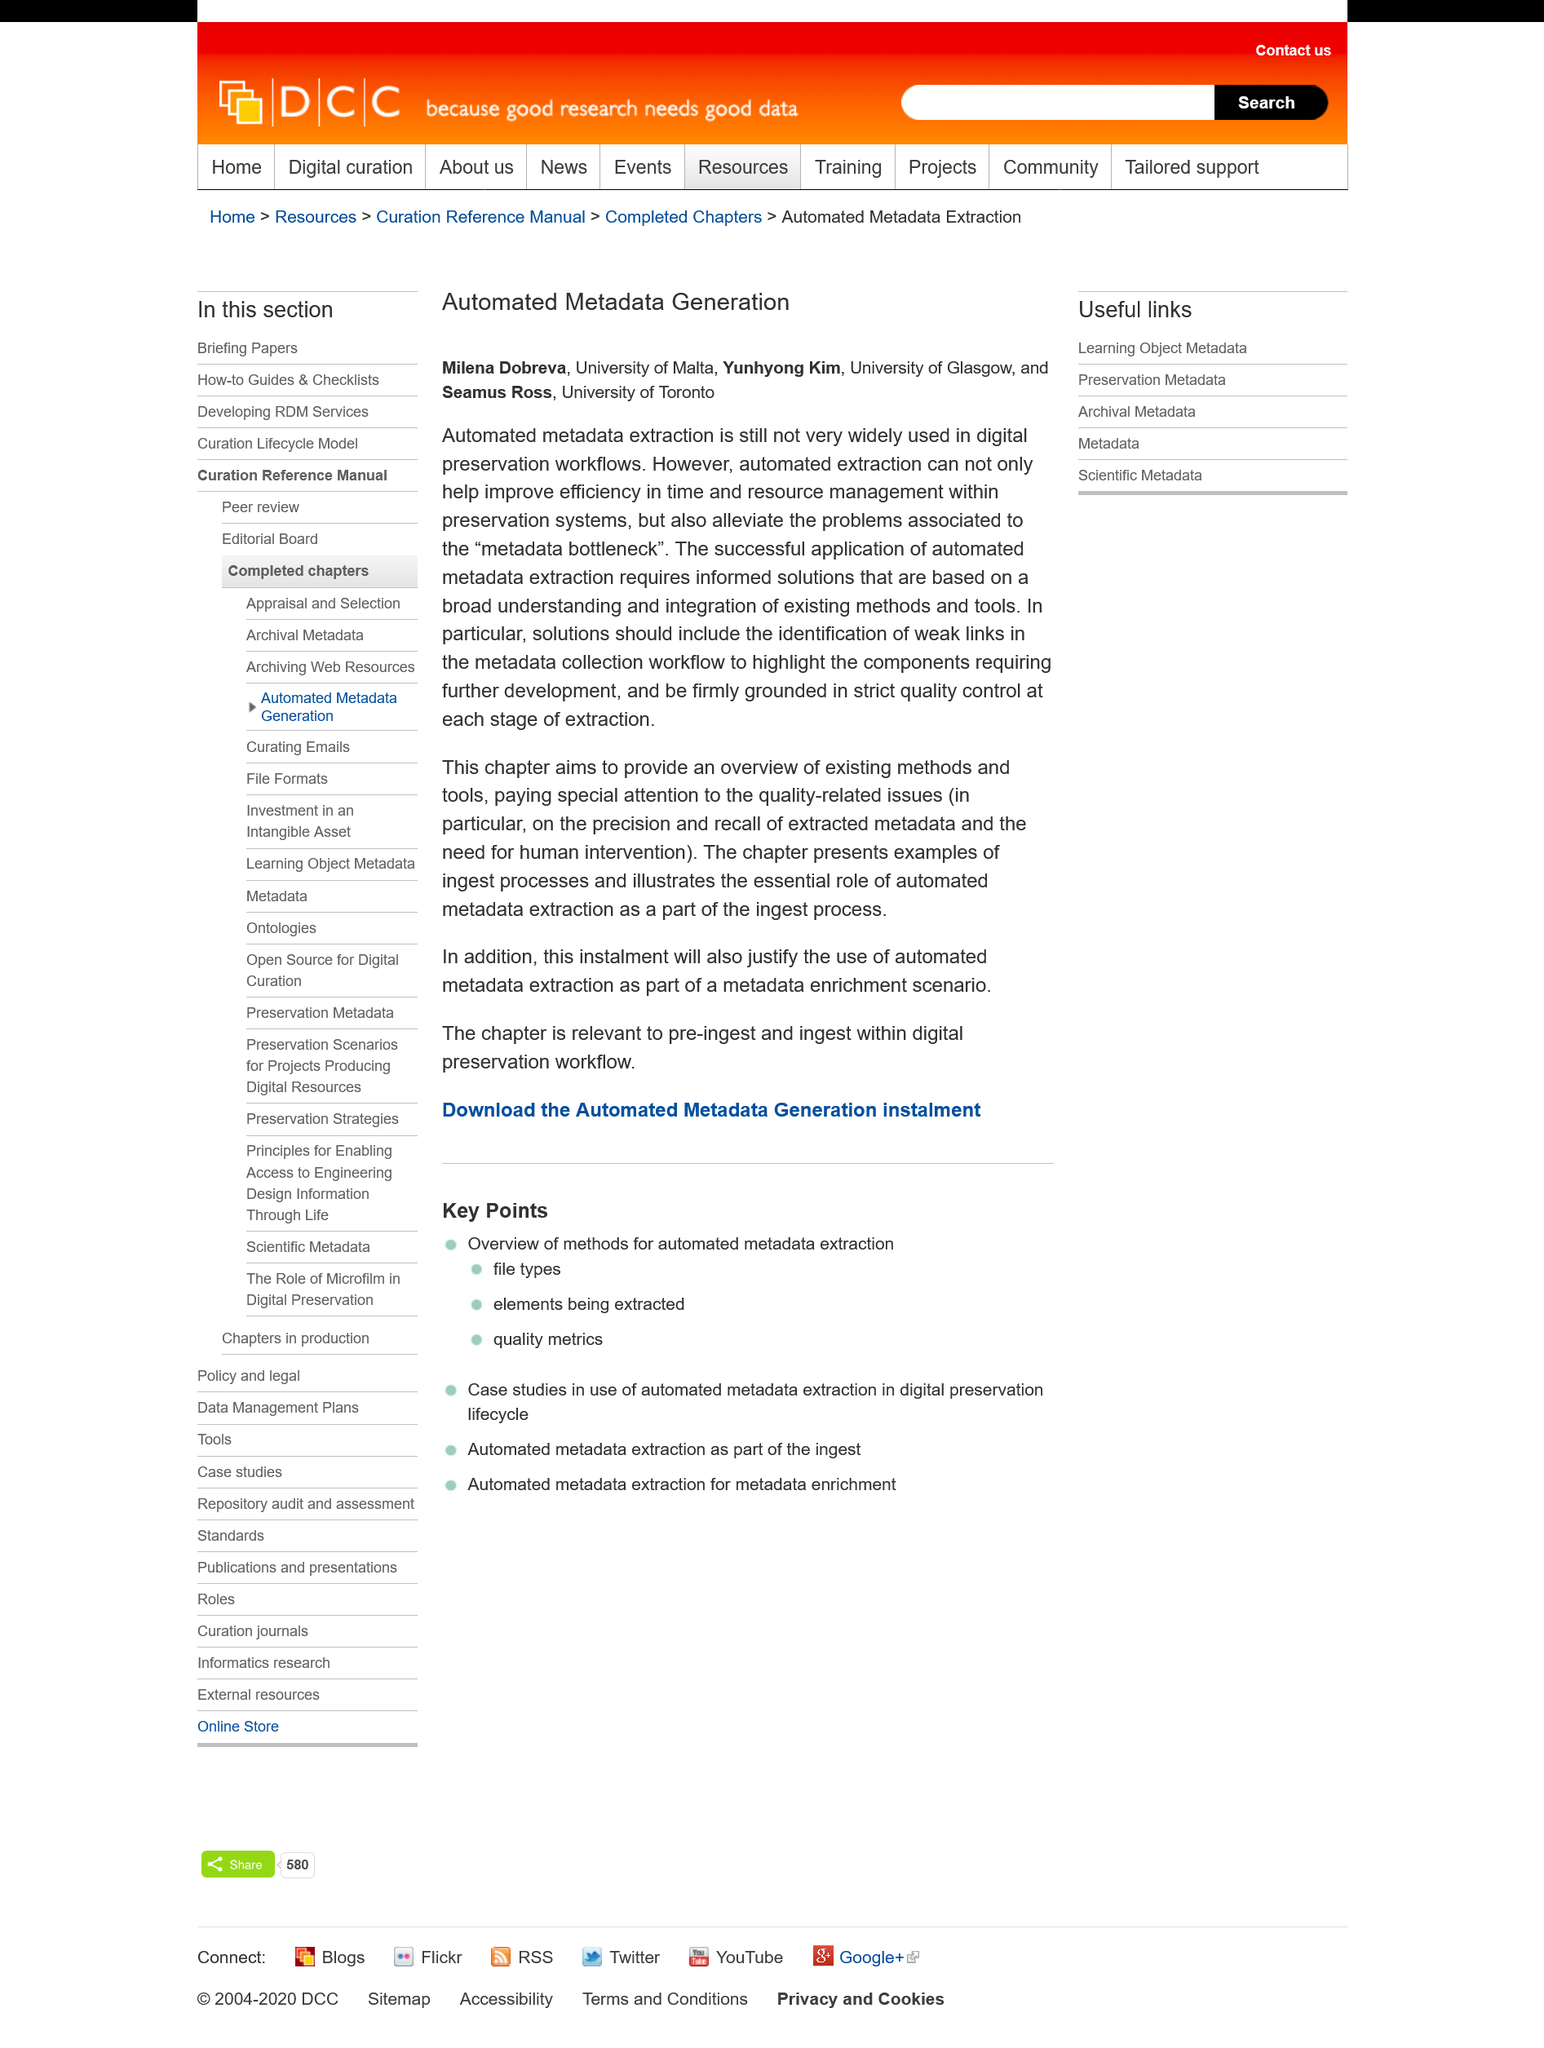Mention a couple of crucial points in this snapshot. The authors of the Automated Metadata Generation paper are Milena Dobreva, Yunhyong Kim, and Seamus Ross. Milena Dobreva is a student from the University of Malta. Automated extraction can be used to alleviate the problems associated with metadata bottleneck. 